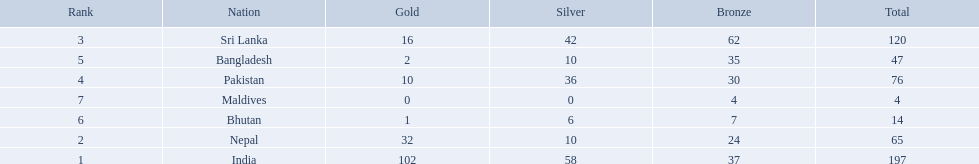What are all the countries listed in the table? India, Nepal, Sri Lanka, Pakistan, Bangladesh, Bhutan, Maldives. Which of these is not india? Nepal, Sri Lanka, Pakistan, Bangladesh, Bhutan, Maldives. Of these, which is first? Nepal. 